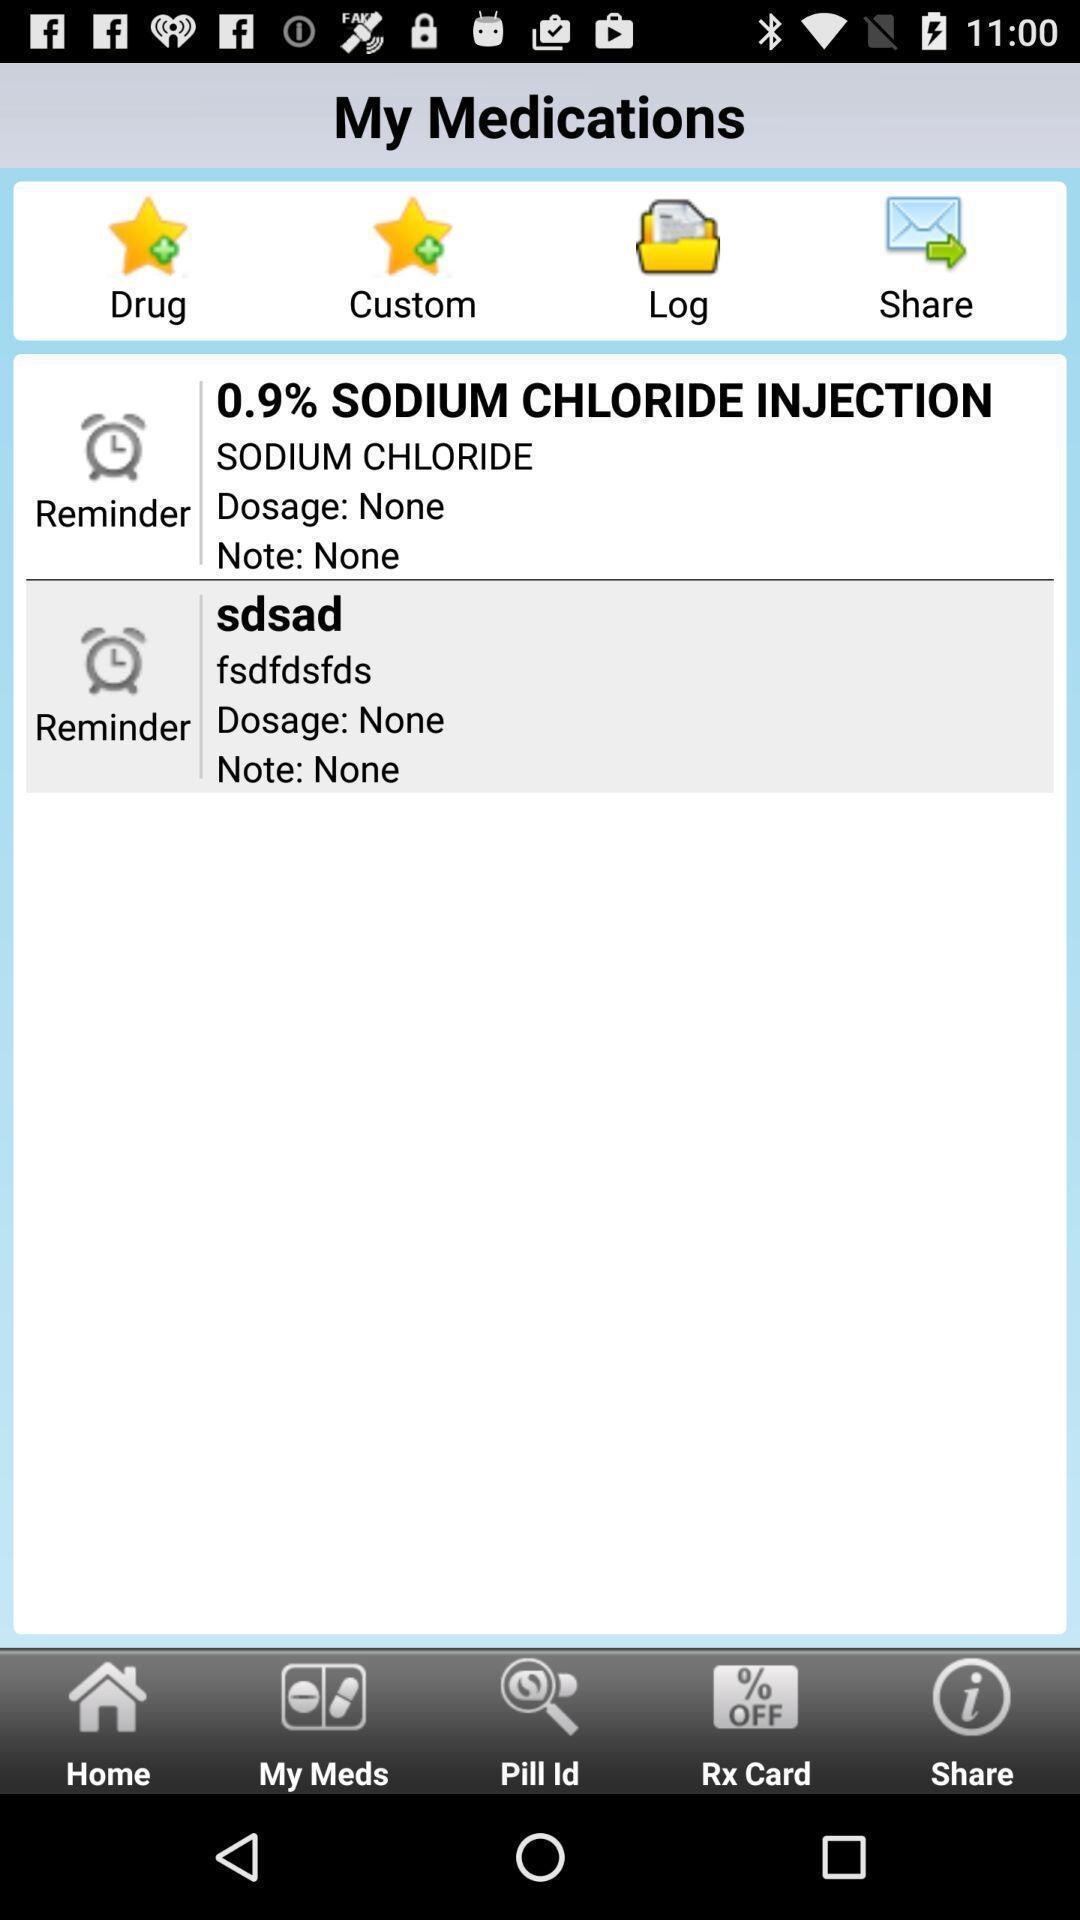Explain what's happening in this screen capture. Screen showing medication page with various options. 